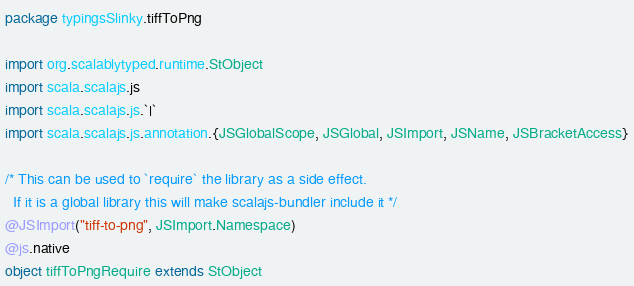Convert code to text. <code><loc_0><loc_0><loc_500><loc_500><_Scala_>package typingsSlinky.tiffToPng

import org.scalablytyped.runtime.StObject
import scala.scalajs.js
import scala.scalajs.js.`|`
import scala.scalajs.js.annotation.{JSGlobalScope, JSGlobal, JSImport, JSName, JSBracketAccess}

/* This can be used to `require` the library as a side effect.
  If it is a global library this will make scalajs-bundler include it */
@JSImport("tiff-to-png", JSImport.Namespace)
@js.native
object tiffToPngRequire extends StObject
</code> 